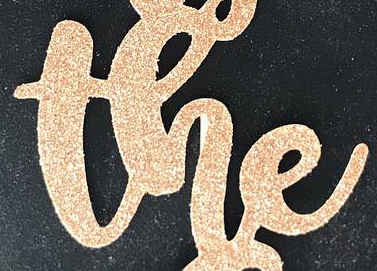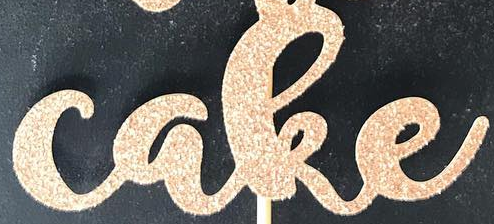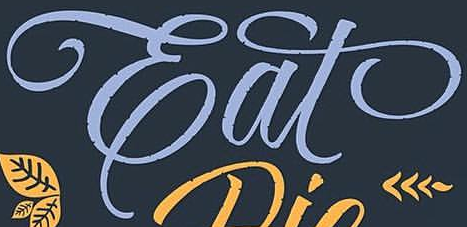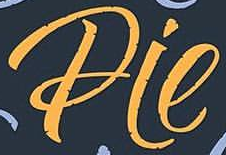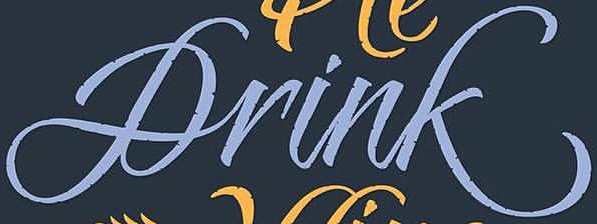What text appears in these images from left to right, separated by a semicolon? the; cake; Eat; Pie; Drink 